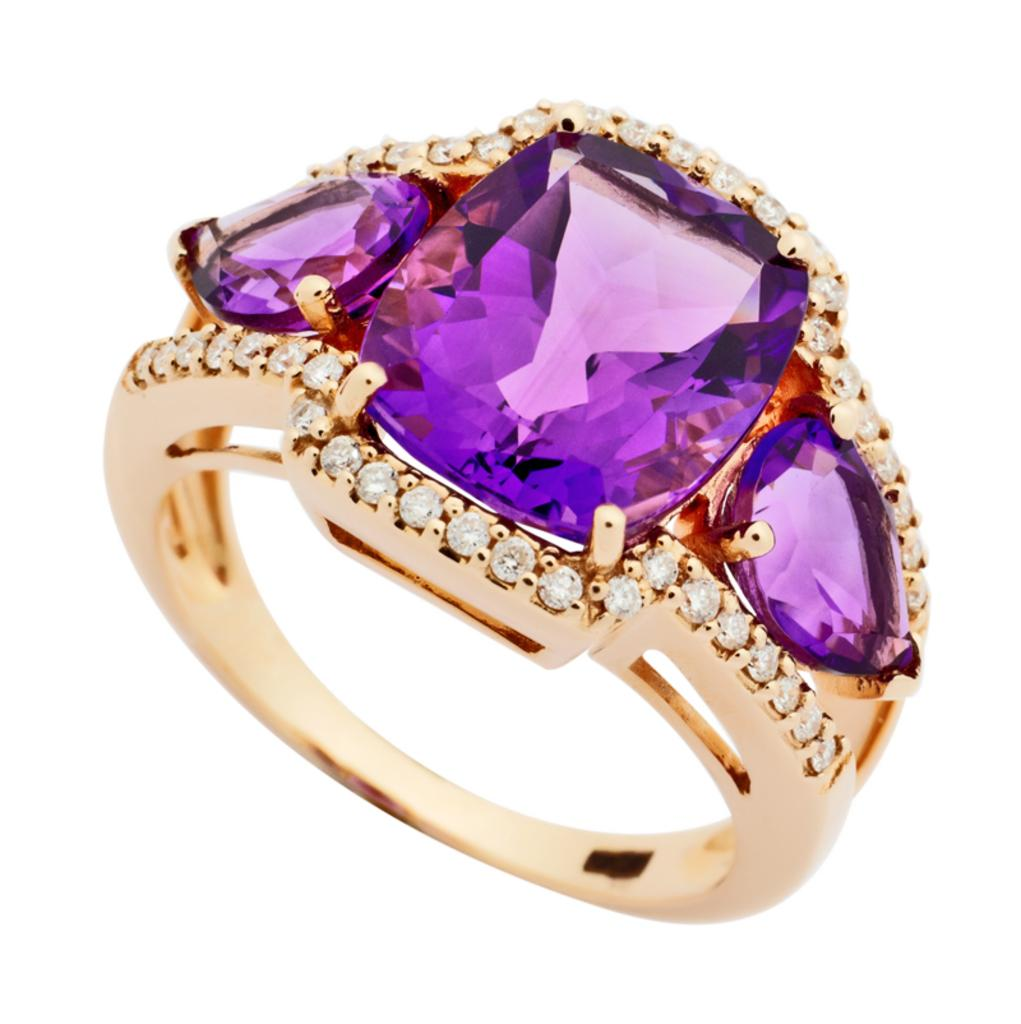What is the main object in the image? There is a ring in the image. What is unique about the ring? The ring has stones on it. How many pies are being baked in the image? There are no pies or baking activity present in the image; it features a ring with stones on it. What type of change is being made to the ring in the image? There is no indication of any change being made to the ring in the image. 